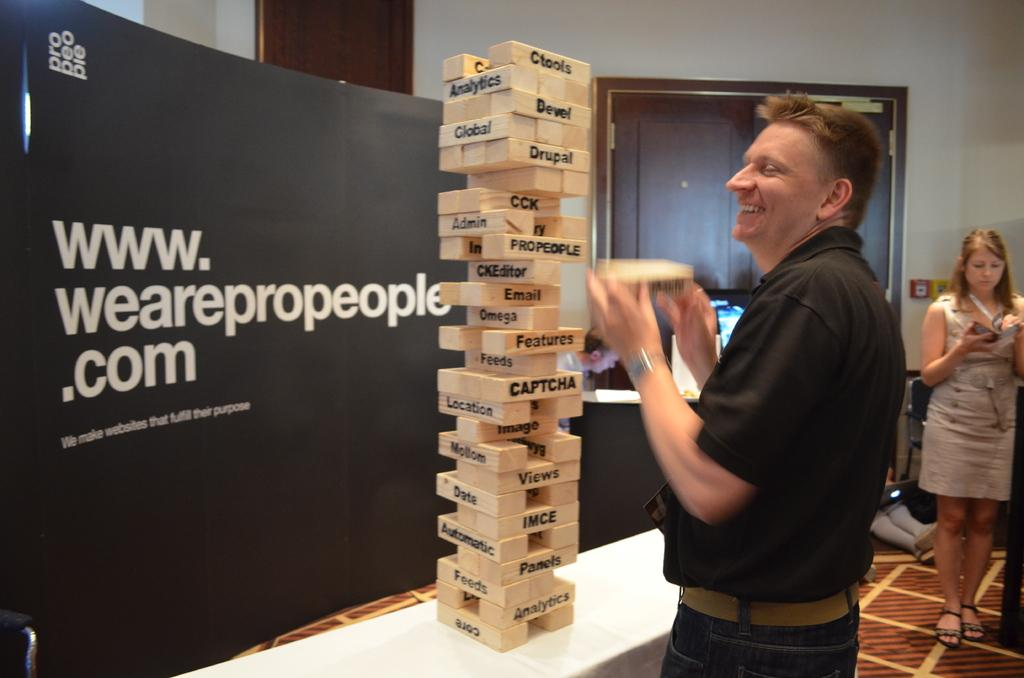<image>
Describe the image concisely. A game of jenga sits in front of a sign saying we are pro people. 